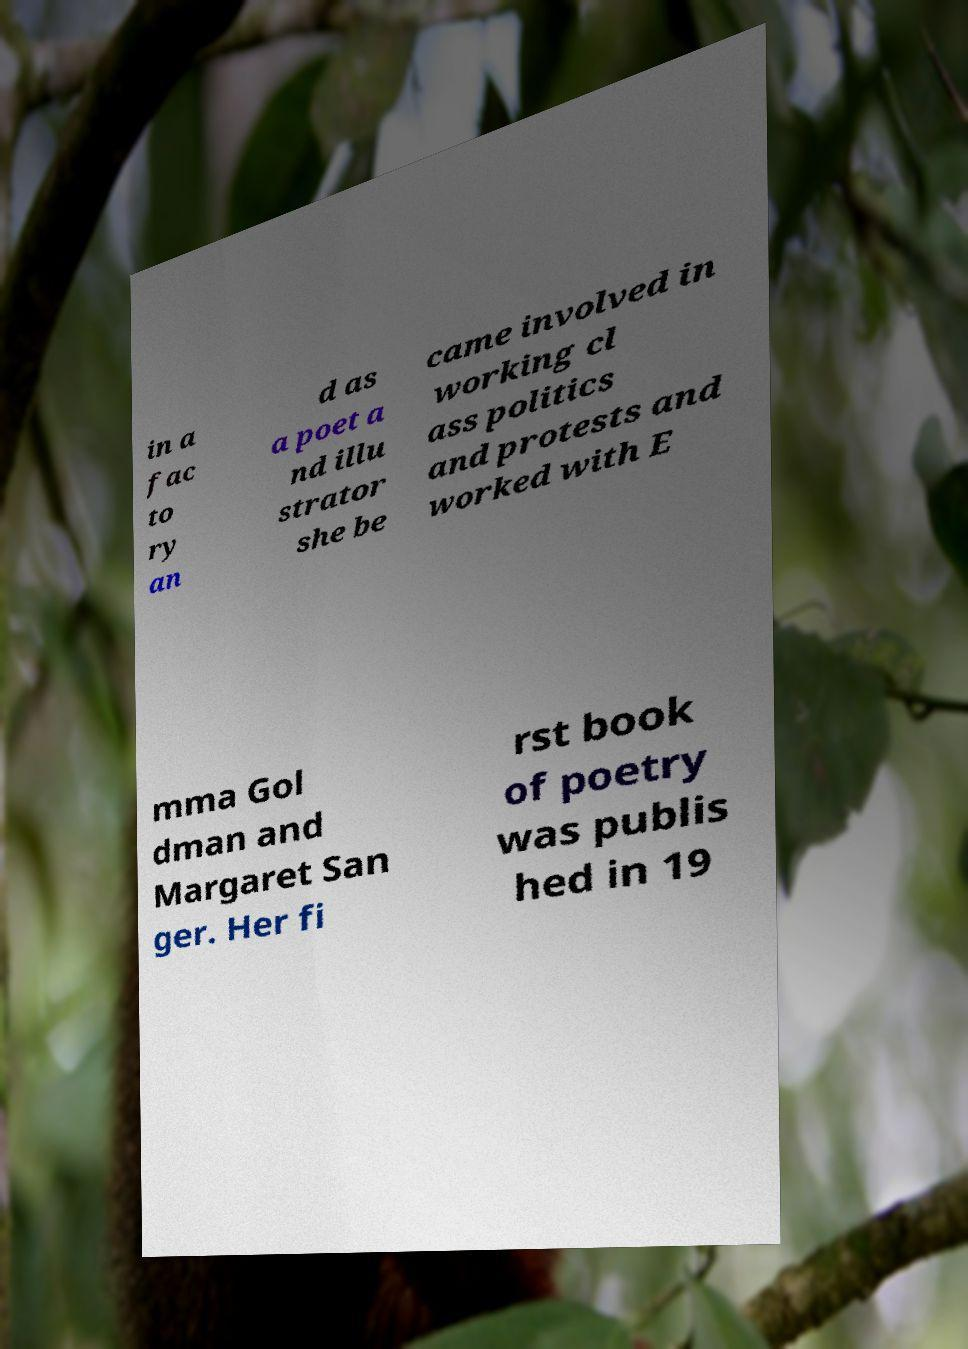Can you accurately transcribe the text from the provided image for me? in a fac to ry an d as a poet a nd illu strator she be came involved in working cl ass politics and protests and worked with E mma Gol dman and Margaret San ger. Her fi rst book of poetry was publis hed in 19 